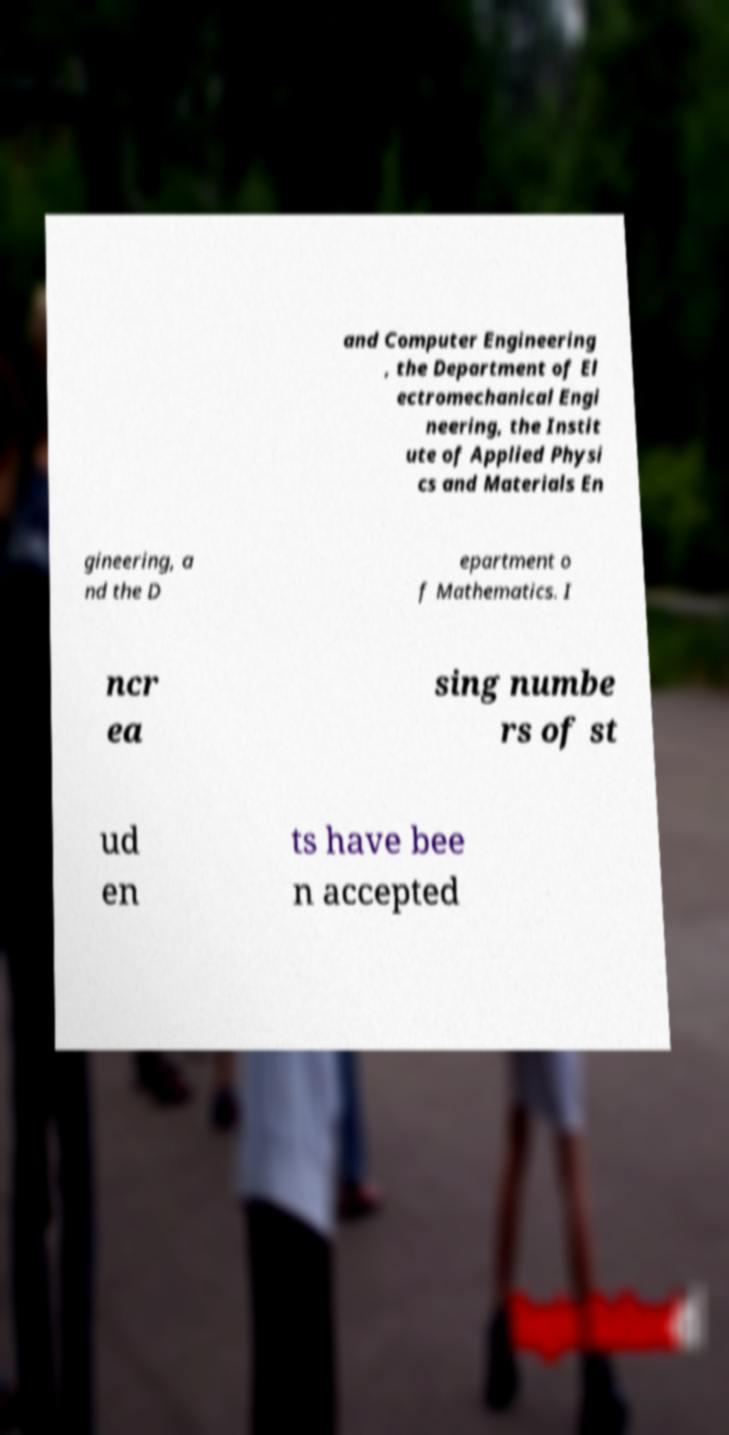Please read and relay the text visible in this image. What does it say? and Computer Engineering , the Department of El ectromechanical Engi neering, the Instit ute of Applied Physi cs and Materials En gineering, a nd the D epartment o f Mathematics. I ncr ea sing numbe rs of st ud en ts have bee n accepted 